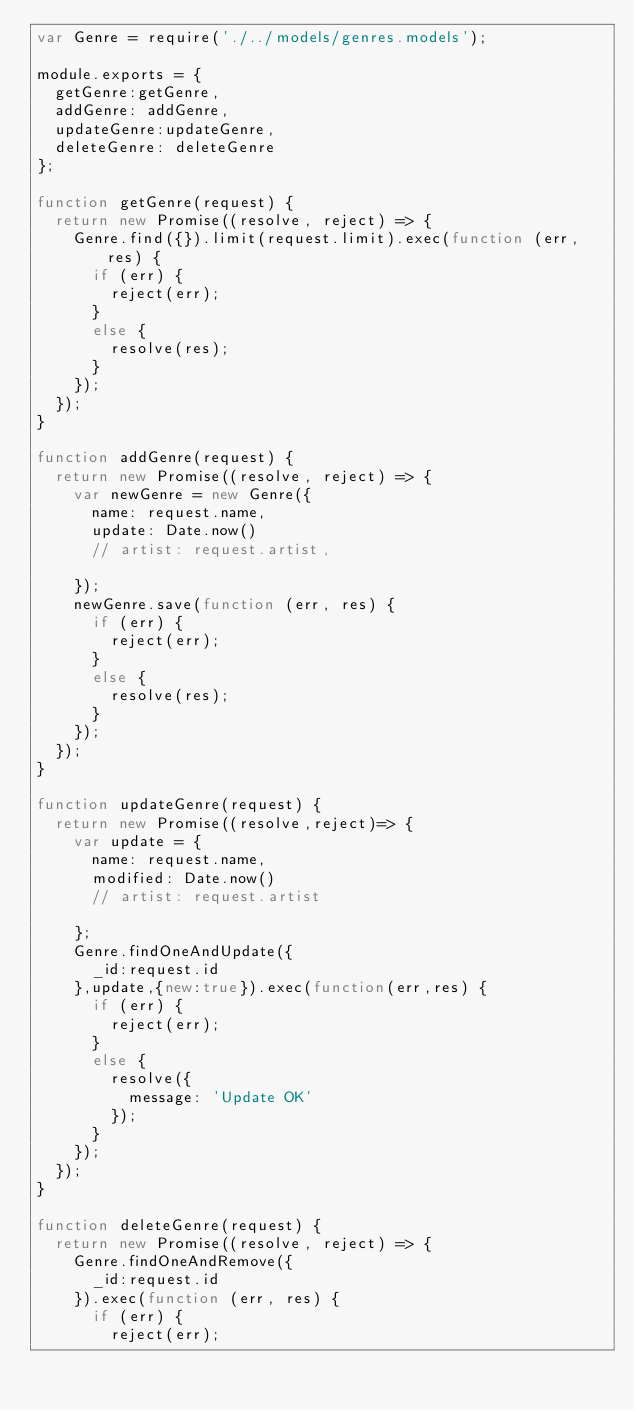<code> <loc_0><loc_0><loc_500><loc_500><_JavaScript_>var Genre = require('./../models/genres.models');

module.exports = {
  getGenre:getGenre,
  addGenre: addGenre,
  updateGenre:updateGenre,
  deleteGenre: deleteGenre
};

function getGenre(request) {
  return new Promise((resolve, reject) => {
    Genre.find({}).limit(request.limit).exec(function (err, res) {
      if (err) {
        reject(err);
      }
      else {
        resolve(res);
      }
    });
  });
}

function addGenre(request) {
  return new Promise((resolve, reject) => {
    var newGenre = new Genre({
      name: request.name,
      update: Date.now()
      // artist: request.artist,

    });
    newGenre.save(function (err, res) {
      if (err) {
        reject(err);
      }
      else {
        resolve(res);
      }
    });
  });
}

function updateGenre(request) {
  return new Promise((resolve,reject)=> {
    var update = {
      name: request.name,
      modified: Date.now()
      // artist: request.artist

    };
    Genre.findOneAndUpdate({
      _id:request.id
    },update,{new:true}).exec(function(err,res) {
      if (err) {
        reject(err);
      }
      else {
        resolve({
          message: 'Update OK'
        });
      }
    });
  });
}

function deleteGenre(request) {
  return new Promise((resolve, reject) => {
    Genre.findOneAndRemove({
      _id:request.id
    }).exec(function (err, res) {
      if (err) {
        reject(err);</code> 